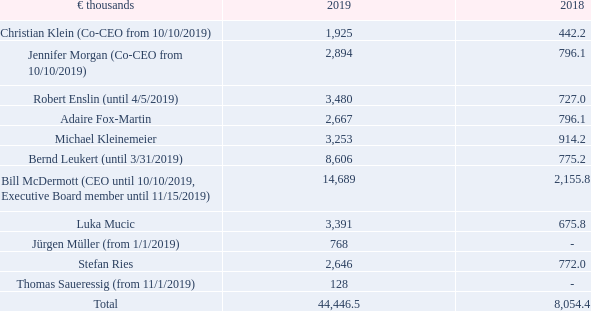Total Expense for Share-Based Payment
Total expense for the share-based payment plans of Executive Board members was determined in accordance with IFRS 2 (Share- Based Payments) and consists exclusively of obligations arising from Executive Board activities.
How was the Total expense for the share-based payment plans of Executive Board members determined? In accordance with ifrs 2 (share- based payments) and consists exclusively of obligations arising from executive board activities. What is the total amount of expense for share-based payment in 2019?
Answer scale should be: thousand. 44,446.5. In which years is the Total Expense for Share-Based Payment provided? 2019, 2018. How many Executive Board members had an expense for share-based payment of less than €1,000 thousand in 2019? Jürgen Müller##Thomas Saueressig
Answer: 2. What was the change in the expense for share-based payment for  Stefan Ries  in 2019 from 2018?
Answer scale should be: thousand.  2,646 - 772.0 
Answer: 1874. What was the average total expense for share-based payment for  Stefan Ries  in 2018 and 2019?
Answer scale should be: thousand.  (2,646 + 772.0)/2 
Answer: 1709. 